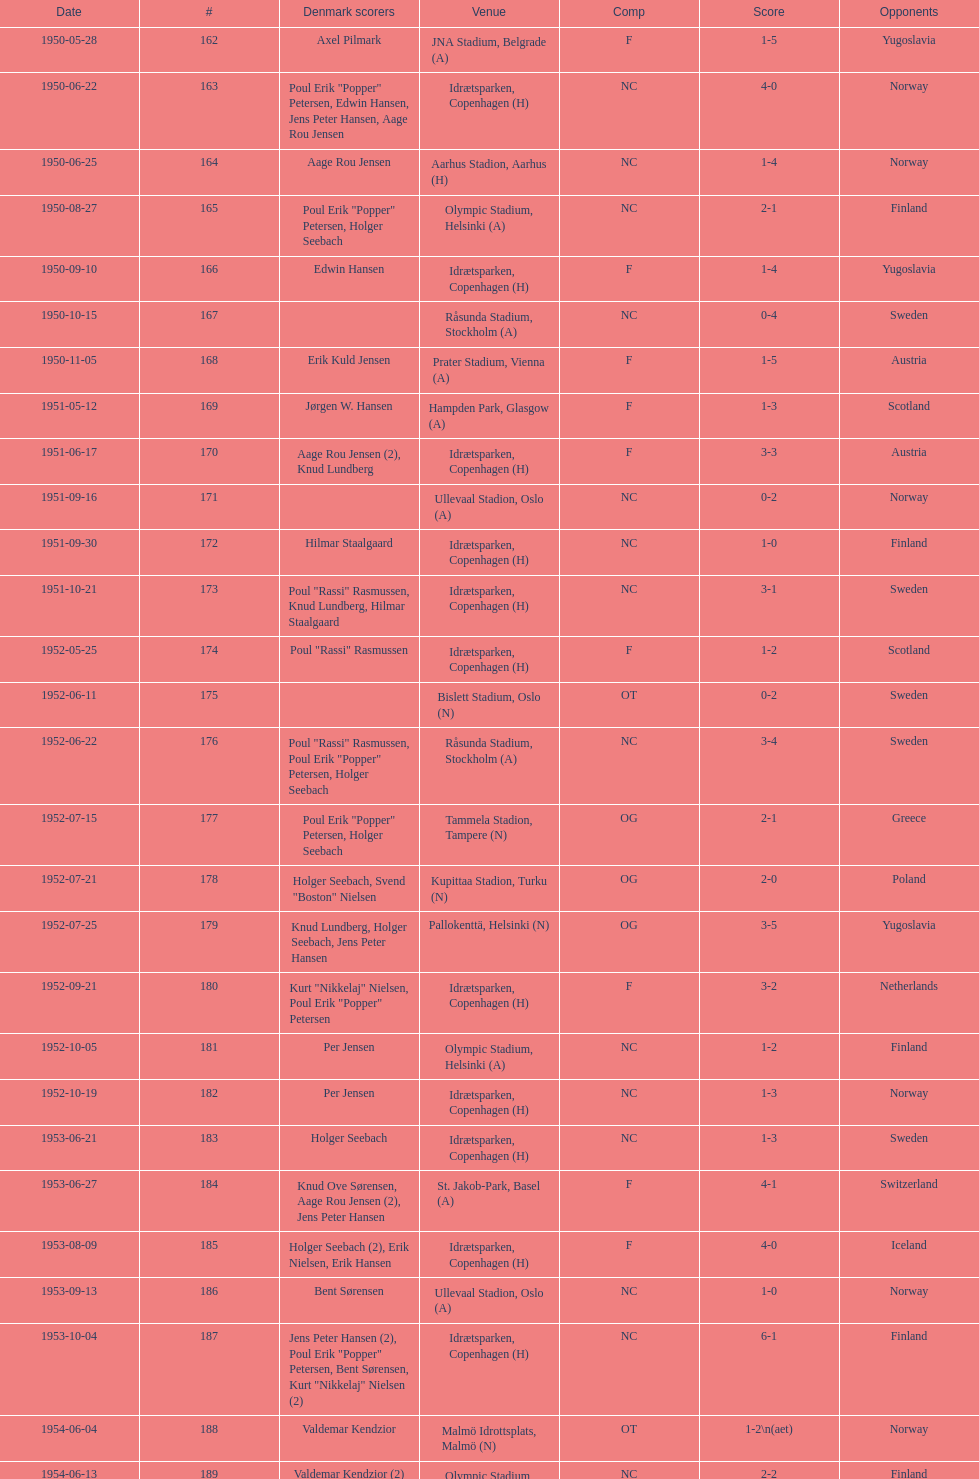What was the difference in score between the two teams in the last game? 1. 